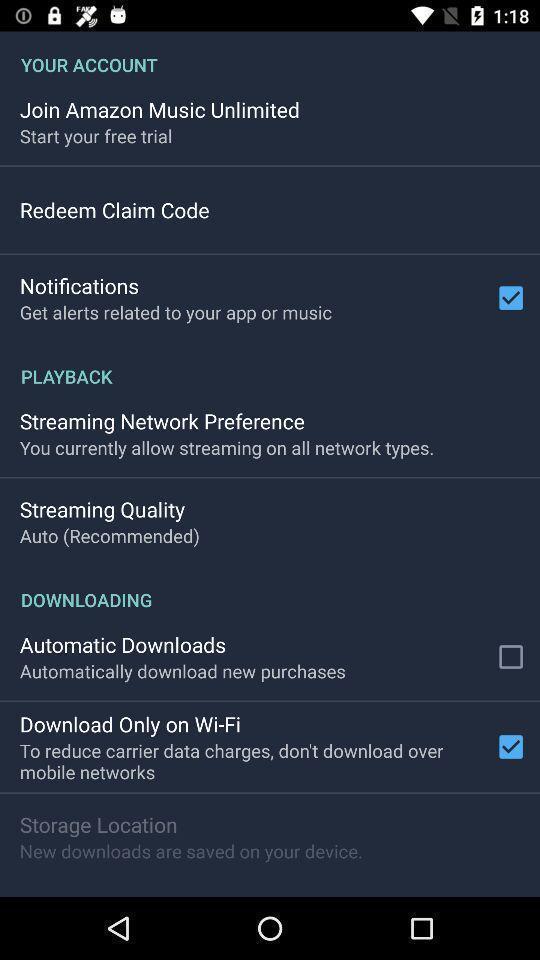Give me a narrative description of this picture. Screen shows account settings. 